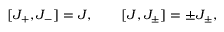<formula> <loc_0><loc_0><loc_500><loc_500>[ J _ { + } , J _ { - } ] = J , \quad [ J , J _ { \pm } ] = \pm J _ { \pm } ,</formula> 